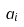Convert formula to latex. <formula><loc_0><loc_0><loc_500><loc_500>a _ { i }</formula> 